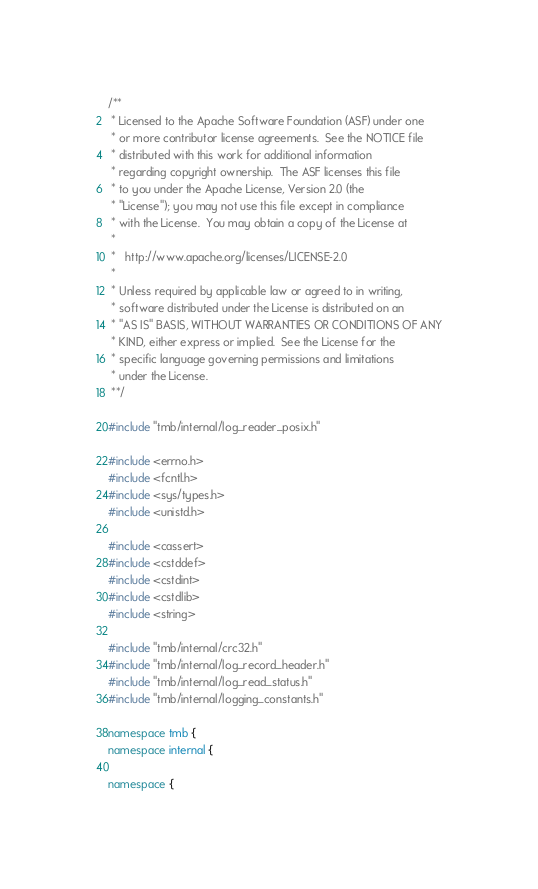Convert code to text. <code><loc_0><loc_0><loc_500><loc_500><_C++_>/**
 * Licensed to the Apache Software Foundation (ASF) under one
 * or more contributor license agreements.  See the NOTICE file
 * distributed with this work for additional information
 * regarding copyright ownership.  The ASF licenses this file
 * to you under the Apache License, Version 2.0 (the
 * "License"); you may not use this file except in compliance
 * with the License.  You may obtain a copy of the License at
 *
 *   http://www.apache.org/licenses/LICENSE-2.0
 *
 * Unless required by applicable law or agreed to in writing,
 * software distributed under the License is distributed on an
 * "AS IS" BASIS, WITHOUT WARRANTIES OR CONDITIONS OF ANY
 * KIND, either express or implied.  See the License for the
 * specific language governing permissions and limitations
 * under the License.
 **/

#include "tmb/internal/log_reader_posix.h"

#include <errno.h>
#include <fcntl.h>
#include <sys/types.h>
#include <unistd.h>

#include <cassert>
#include <cstddef>
#include <cstdint>
#include <cstdlib>
#include <string>

#include "tmb/internal/crc32.h"
#include "tmb/internal/log_record_header.h"
#include "tmb/internal/log_read_status.h"
#include "tmb/internal/logging_constants.h"

namespace tmb {
namespace internal {

namespace {
</code> 